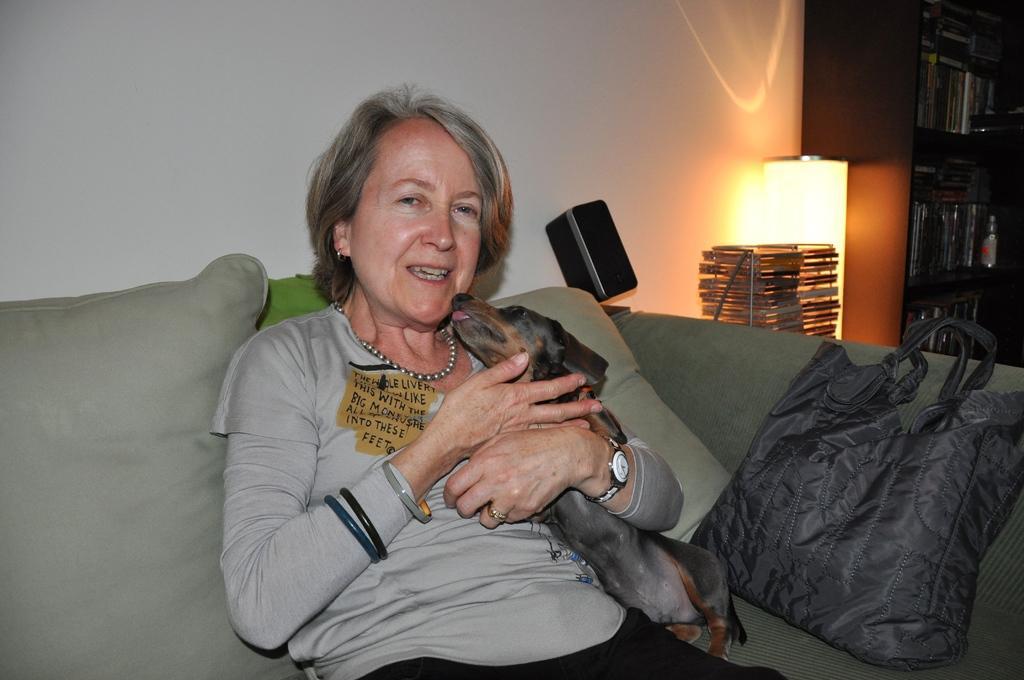In one or two sentences, can you explain what this image depicts? In this image I can see a person smiling and holding the dog. And she is sitting on the couch. On the couch there is a bag and pillows. At the back of her there is a light and the cupboard. 